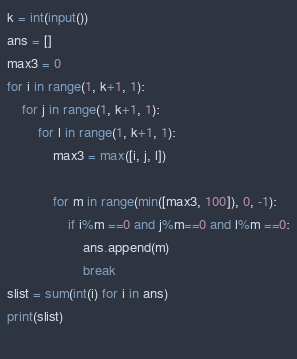Convert code to text. <code><loc_0><loc_0><loc_500><loc_500><_Python_>k = int(input())
ans = []
max3 = 0
for i in range(1, k+1, 1):
    for j in range(1, k+1, 1):
        for l in range(1, k+1, 1):
            max3 = max([i, j, l])
            
            for m in range(min([max3, 100]), 0, -1):
                if i%m ==0 and j%m==0 and l%m ==0:
                    ans.append(m)
                    break
slist = sum(int(i) for i in ans)
print(slist)
    </code> 